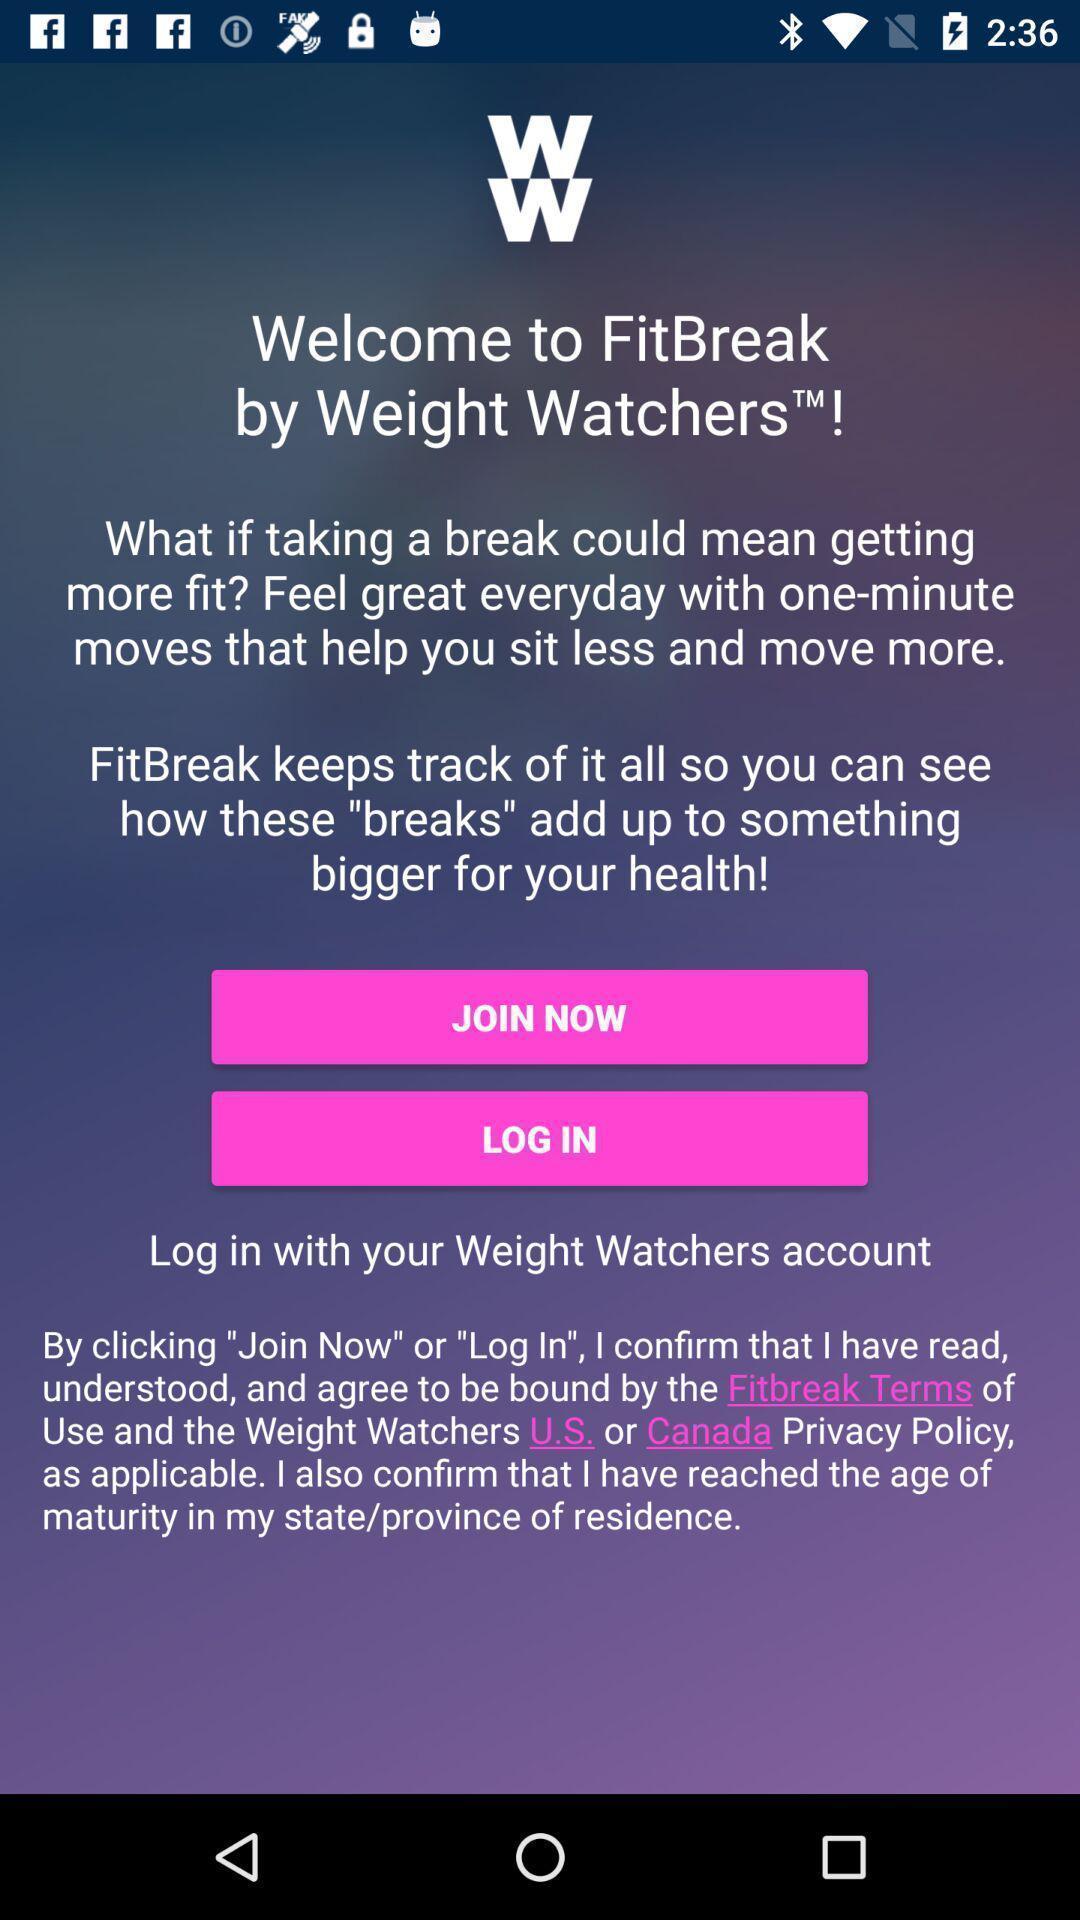Summarize the information in this screenshot. Welcome page. 